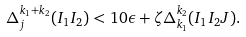Convert formula to latex. <formula><loc_0><loc_0><loc_500><loc_500>\Delta _ { j } ^ { k _ { 1 } + k _ { 2 } } ( I _ { 1 } I _ { 2 } ) < 1 0 \epsilon + \zeta \Delta _ { k _ { 1 } } ^ { k _ { 2 } } ( I _ { 1 } I _ { 2 } J ) .</formula> 